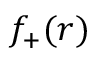<formula> <loc_0><loc_0><loc_500><loc_500>f _ { + } ( r )</formula> 